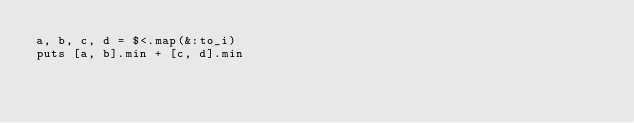<code> <loc_0><loc_0><loc_500><loc_500><_Ruby_>a, b, c, d = $<.map(&:to_i)
puts [a, b].min + [c, d].min</code> 